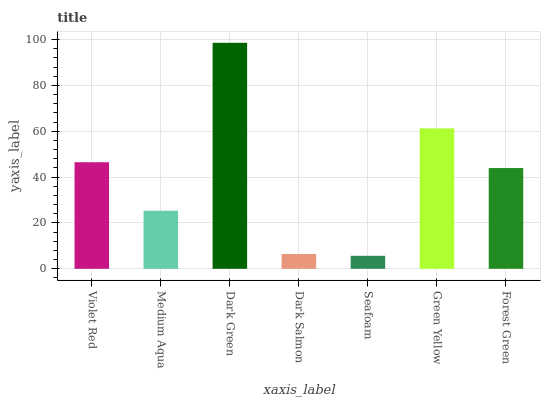Is Seafoam the minimum?
Answer yes or no. Yes. Is Dark Green the maximum?
Answer yes or no. Yes. Is Medium Aqua the minimum?
Answer yes or no. No. Is Medium Aqua the maximum?
Answer yes or no. No. Is Violet Red greater than Medium Aqua?
Answer yes or no. Yes. Is Medium Aqua less than Violet Red?
Answer yes or no. Yes. Is Medium Aqua greater than Violet Red?
Answer yes or no. No. Is Violet Red less than Medium Aqua?
Answer yes or no. No. Is Forest Green the high median?
Answer yes or no. Yes. Is Forest Green the low median?
Answer yes or no. Yes. Is Seafoam the high median?
Answer yes or no. No. Is Violet Red the low median?
Answer yes or no. No. 